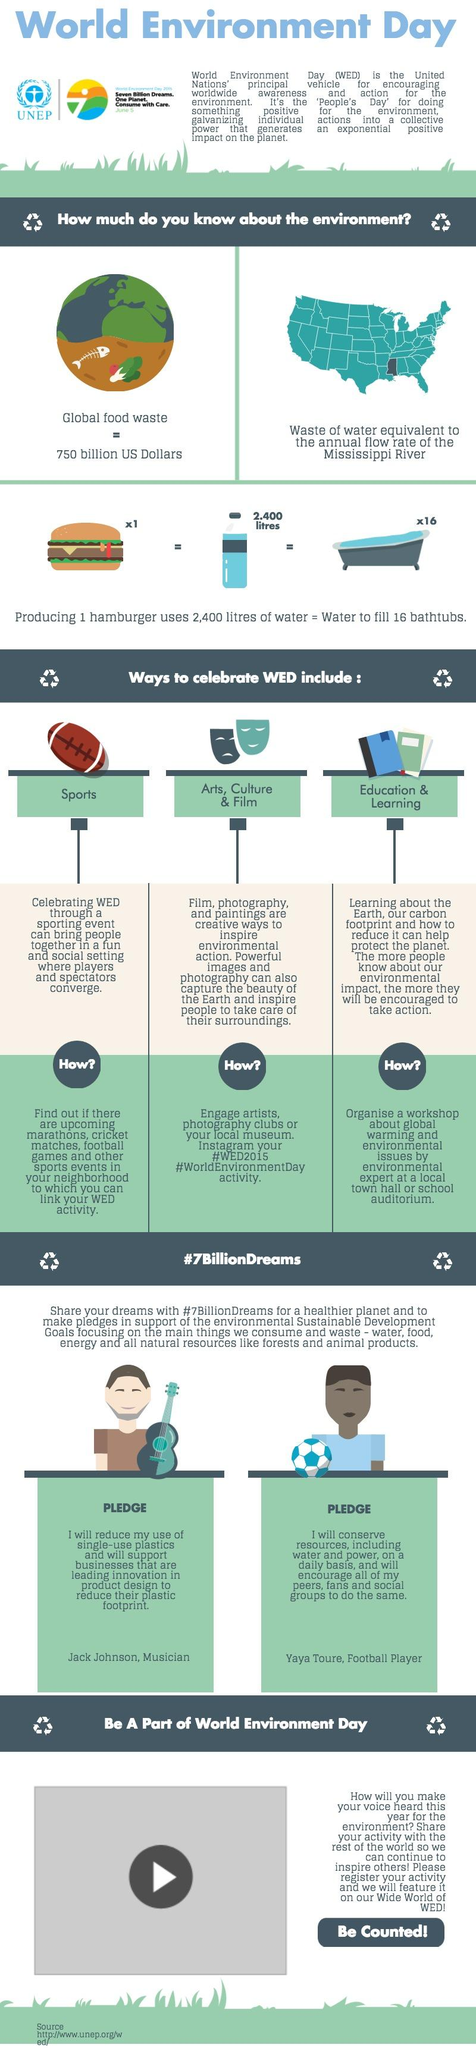List a handful of essential elements in this visual. On Instagram, hashtags can be used to categorize and make posts discoverable. The specific hashtags that can be used may vary, but examples include "#WED2015" and "#WorldEnvironmentDay" to mark related posts on World Environment Day in 2015. The value of global food waste is estimated to be 750 billion US dollars. The annual flow rate of the Mississippi River is approximately 16,000,000,000 cubic meters, and the amount of water wastage that would result from using 250,000 cubic meters of water for irrigation purposes can be calculated by multiplying the flow rate by the percentage of water lost due to evaporation and transpiration. On what day is WED celebrated? World Environment Day (WED) can be celebrated through various mediums, including sports, art, culture, film, education, and learning. 